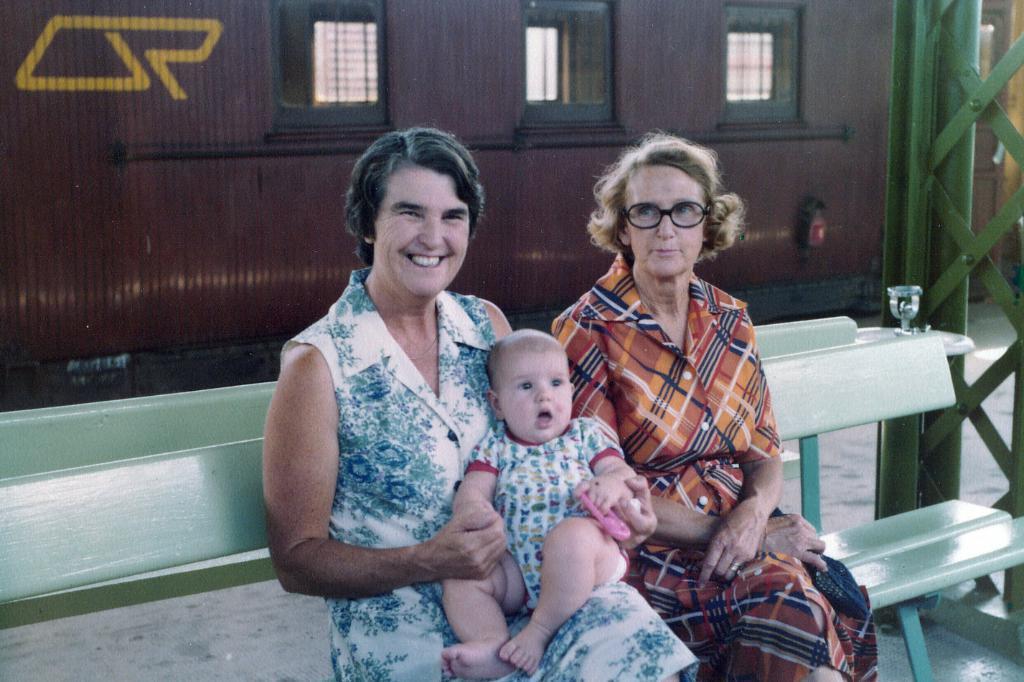Please provide a concise description of this image. It looks like a railway station, here a woman is sitting on the bench and also holding the baby, she is smiling beside her there is another woman, she wore spectacles behind them it may be train in brown color. On the right side there are iron rods. 